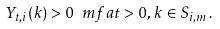Convert formula to latex. <formula><loc_0><loc_0><loc_500><loc_500>Y _ { t , i } ( k ) > 0 \ m f a t > 0 , \, k \in S _ { i , m } \, .</formula> 